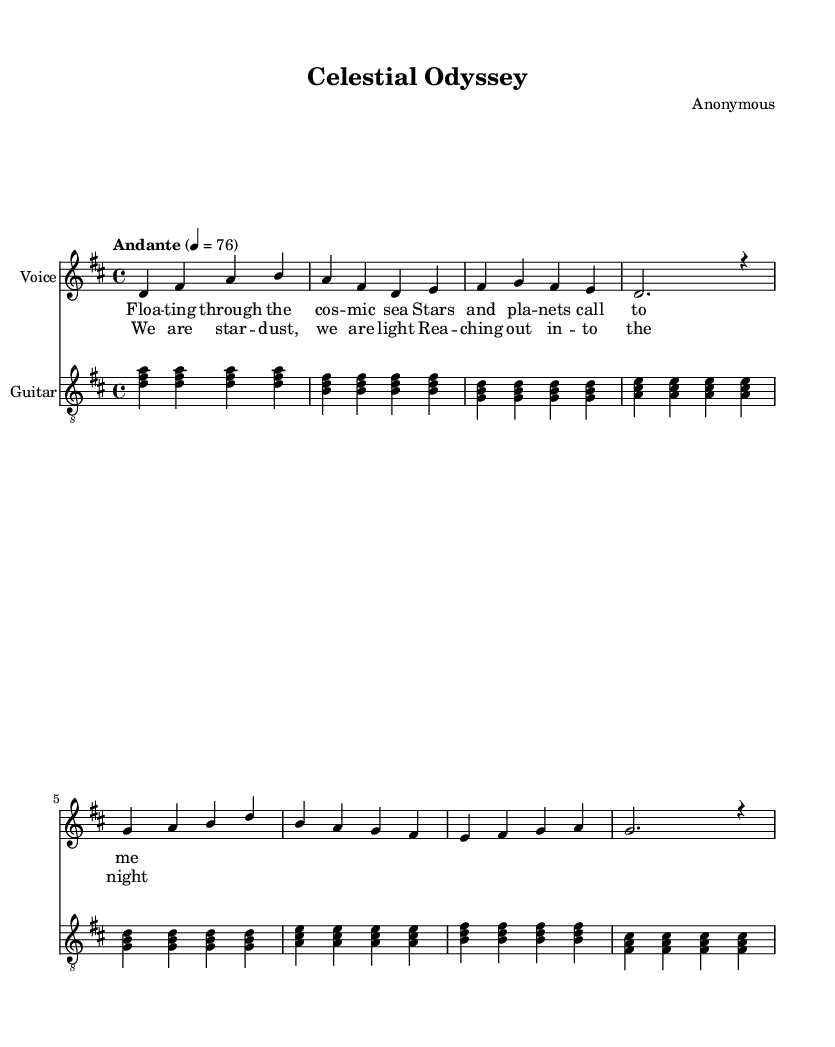What is the key signature of this music? The key signature indicates D major, which has two sharps (F# and C#). This can be found at the beginning of the staff where the key signature is shown.
Answer: D major What is the time signature of this music? The time signature is 4/4, which means there are four beats in each measure and a quarter note receives one beat. This is also found at the beginning of the score, indicated directly after the key signature.
Answer: 4/4 What is the tempo marking for this piece? The tempo marking is "Andante," which indicates a moderate walking pace, and is marked with a metronome mark of 76 beats per minute. This is shown in the tempo text above the staves.
Answer: Andante How many measures are in the verse? The verse consists of eight measures, which can be counted in the voice staff where each group of notes represents a measure.
Answer: 8 What are the climax words of the chorus? The climax words of the chorus are "star dust," which can be inferred from the lyrical phrasing that emphasizes those words in the structure of the chorus.
Answer: star dust What instrumental accompaniment is used with the voice? The instrumental accompaniment is the guitar, which can be identified by looking at the second staff labeled specifically with "Guitar" beneath the vocal staff.
Answer: Guitar What is the overall theme of the lyrics? The overall theme of the lyrics revolves around space exploration and celestial bodies, as indicated by phrases related to "cosmic sea," "stars," and "night." This theme is evident in both verse and chorus lyrics.
Answer: Space exploration 